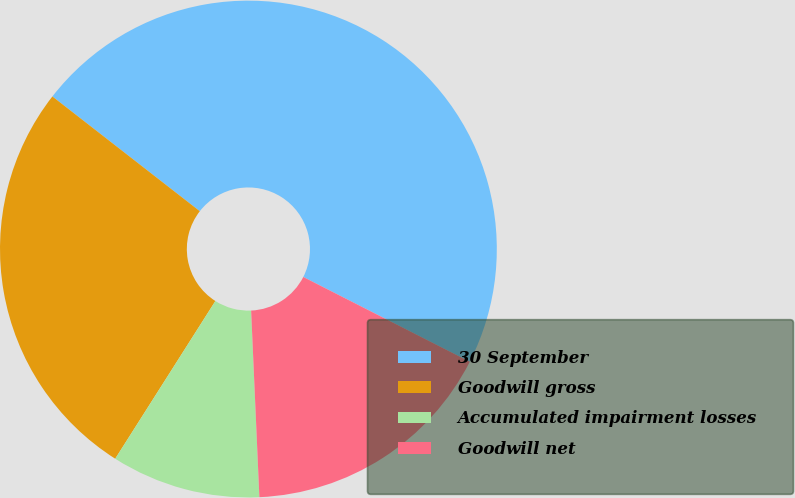Convert chart. <chart><loc_0><loc_0><loc_500><loc_500><pie_chart><fcel>30 September<fcel>Goodwill gross<fcel>Accumulated impairment losses<fcel>Goodwill net<nl><fcel>46.97%<fcel>26.52%<fcel>9.71%<fcel>16.8%<nl></chart> 